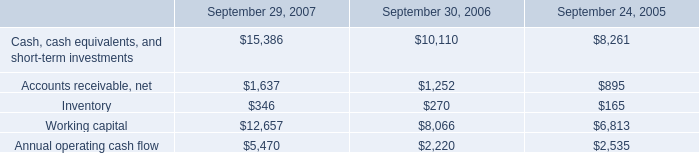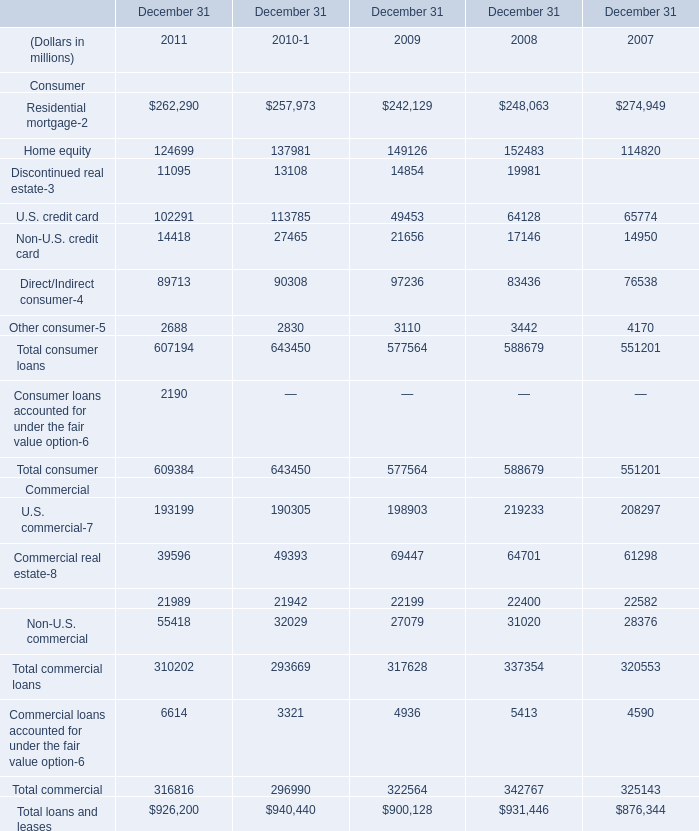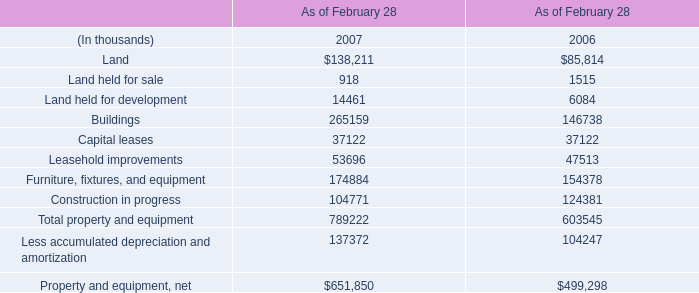what was the percentage change in inventory between 2006 and 2007? 
Computations: ((346 - 270) / 270)
Answer: 0.28148. 